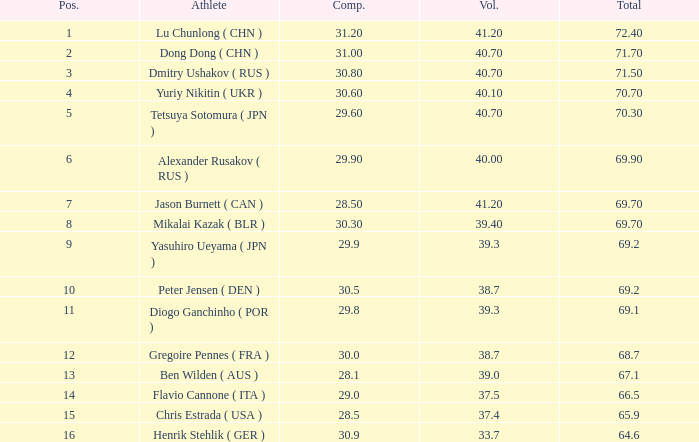What's the total of the position of 1? None. 